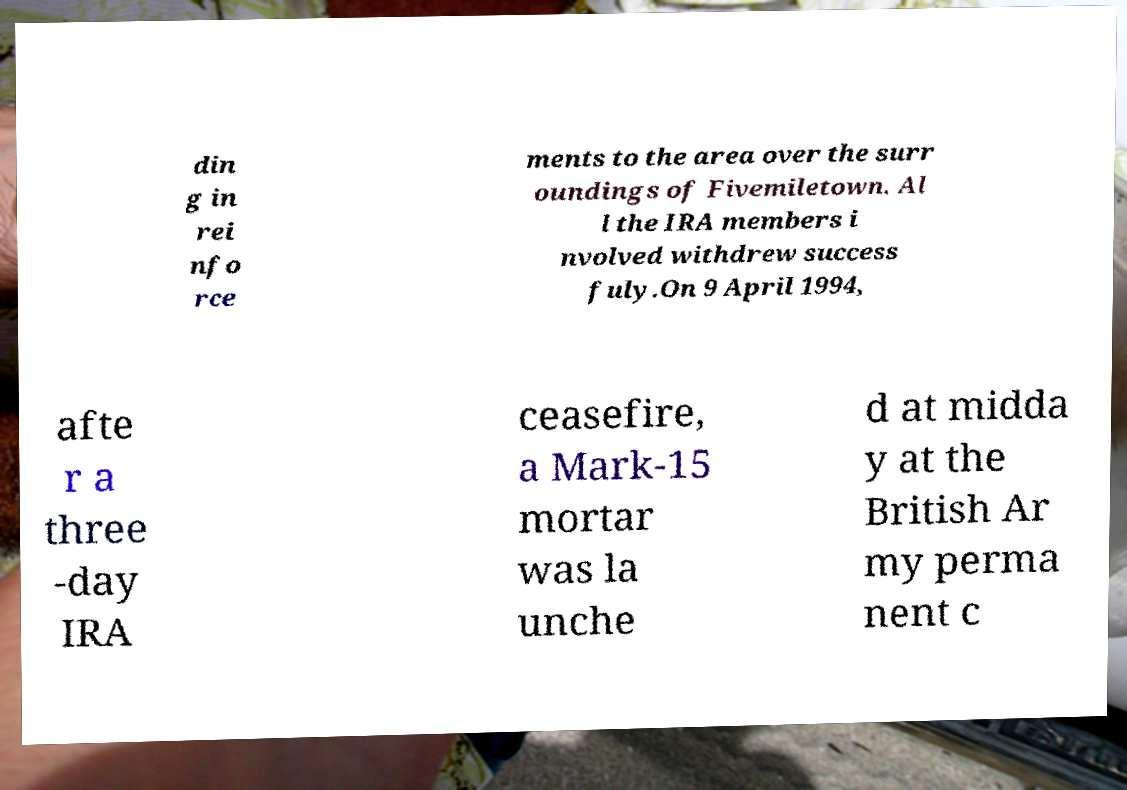Could you assist in decoding the text presented in this image and type it out clearly? din g in rei nfo rce ments to the area over the surr oundings of Fivemiletown. Al l the IRA members i nvolved withdrew success fuly.On 9 April 1994, afte r a three -day IRA ceasefire, a Mark-15 mortar was la unche d at midda y at the British Ar my perma nent c 